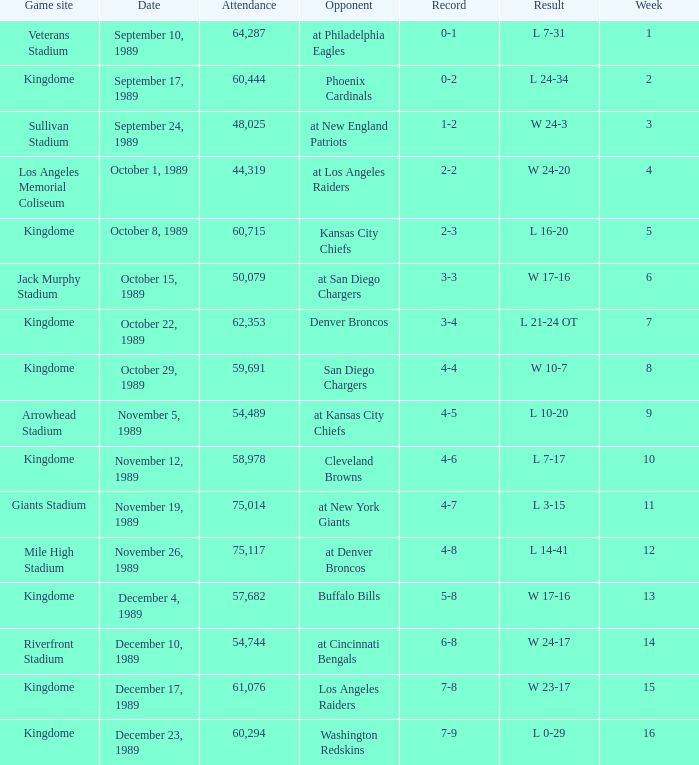Name the result for kingdome game site and opponent of denver broncos L 21-24 OT. 